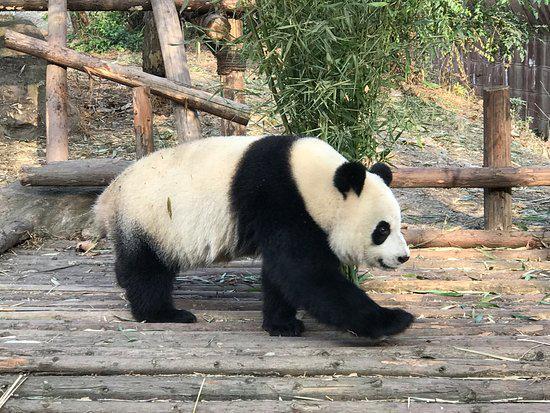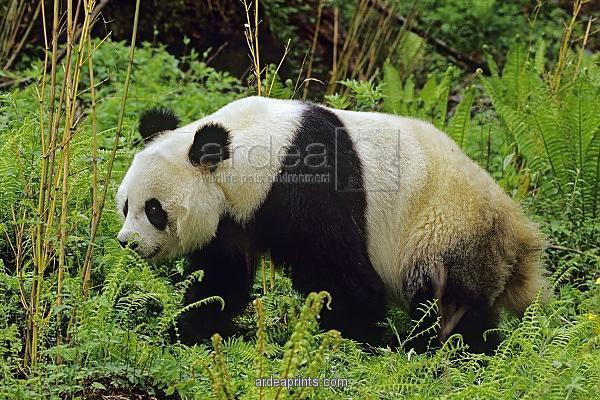The first image is the image on the left, the second image is the image on the right. For the images shown, is this caption "All pandas are walking on all fours, and at least one panda is walking rightward with the camera-facing front paw forward." true? Answer yes or no. Yes. The first image is the image on the left, the second image is the image on the right. Evaluate the accuracy of this statement regarding the images: "In at least one image therei sa panda with a single black stripe on it's back walking in grass white facing forward right.". Is it true? Answer yes or no. No. 